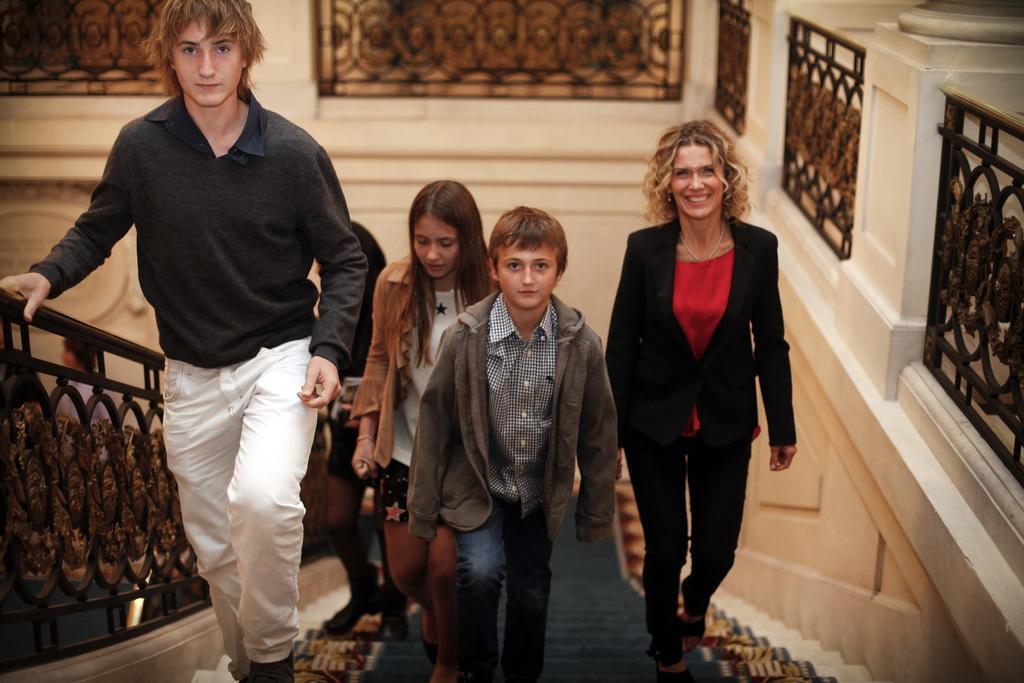Could you give a brief overview of what you see in this image? In this image there are so many people climbing up from the stairs also there is a fence beside them. 